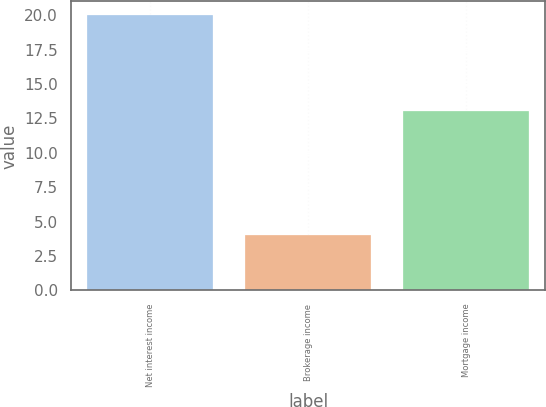<chart> <loc_0><loc_0><loc_500><loc_500><bar_chart><fcel>Net interest income<fcel>Brokerage income<fcel>Mortgage income<nl><fcel>20<fcel>4<fcel>13<nl></chart> 